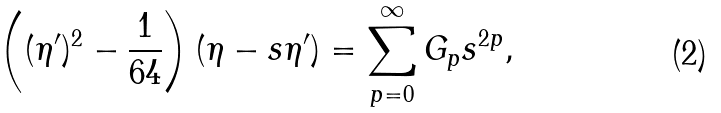<formula> <loc_0><loc_0><loc_500><loc_500>\left ( ( \eta ^ { \prime } ) ^ { 2 } - \frac { 1 } { 6 4 } \right ) ( \eta - s \eta ^ { \prime } ) = \sum ^ { \infty } _ { p = 0 } G _ { p } s ^ { 2 p } ,</formula> 